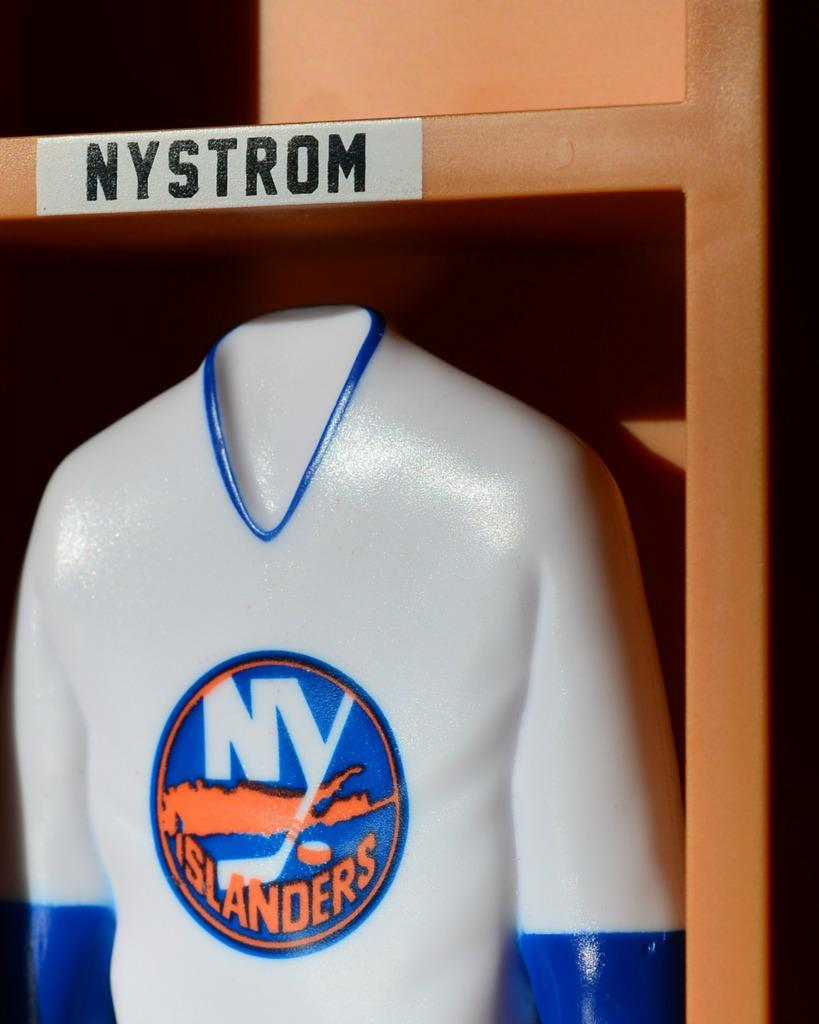<image>
Give a short and clear explanation of the subsequent image. A white shirt says "NY ISLANDERS" on the front. 